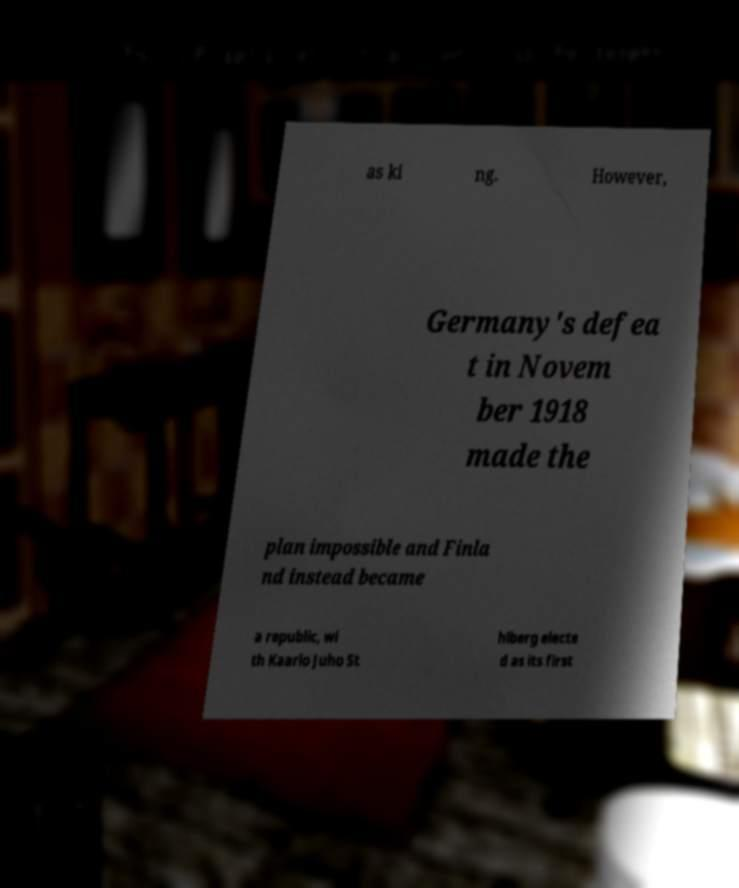Please identify and transcribe the text found in this image. as ki ng. However, Germany's defea t in Novem ber 1918 made the plan impossible and Finla nd instead became a republic, wi th Kaarlo Juho St hlberg electe d as its first 